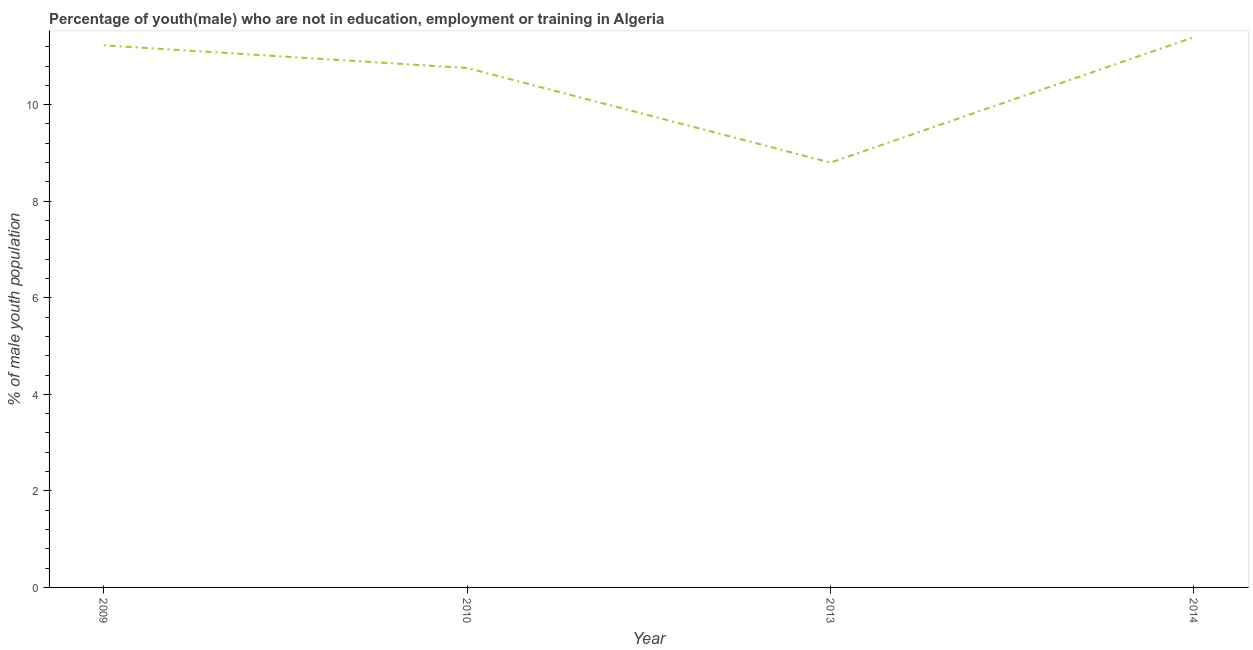What is the unemployed male youth population in 2013?
Provide a short and direct response. 8.8. Across all years, what is the maximum unemployed male youth population?
Ensure brevity in your answer.  11.4. Across all years, what is the minimum unemployed male youth population?
Give a very brief answer. 8.8. What is the sum of the unemployed male youth population?
Your answer should be compact. 42.19. What is the difference between the unemployed male youth population in 2009 and 2014?
Your response must be concise. -0.17. What is the average unemployed male youth population per year?
Ensure brevity in your answer.  10.55. What is the median unemployed male youth population?
Your response must be concise. 10.99. Do a majority of the years between 2010 and 2009 (inclusive) have unemployed male youth population greater than 2.4 %?
Your answer should be very brief. No. What is the ratio of the unemployed male youth population in 2010 to that in 2014?
Your answer should be compact. 0.94. Is the unemployed male youth population in 2009 less than that in 2013?
Your answer should be compact. No. What is the difference between the highest and the second highest unemployed male youth population?
Provide a succinct answer. 0.17. What is the difference between the highest and the lowest unemployed male youth population?
Offer a terse response. 2.6. How many lines are there?
Ensure brevity in your answer.  1. How many years are there in the graph?
Give a very brief answer. 4. What is the difference between two consecutive major ticks on the Y-axis?
Your answer should be very brief. 2. Are the values on the major ticks of Y-axis written in scientific E-notation?
Offer a very short reply. No. Does the graph contain any zero values?
Your response must be concise. No. Does the graph contain grids?
Your answer should be very brief. No. What is the title of the graph?
Your answer should be compact. Percentage of youth(male) who are not in education, employment or training in Algeria. What is the label or title of the Y-axis?
Make the answer very short. % of male youth population. What is the % of male youth population of 2009?
Keep it short and to the point. 11.23. What is the % of male youth population of 2010?
Your response must be concise. 10.76. What is the % of male youth population in 2013?
Offer a terse response. 8.8. What is the % of male youth population of 2014?
Provide a succinct answer. 11.4. What is the difference between the % of male youth population in 2009 and 2010?
Give a very brief answer. 0.47. What is the difference between the % of male youth population in 2009 and 2013?
Your answer should be compact. 2.43. What is the difference between the % of male youth population in 2009 and 2014?
Your answer should be very brief. -0.17. What is the difference between the % of male youth population in 2010 and 2013?
Provide a succinct answer. 1.96. What is the difference between the % of male youth population in 2010 and 2014?
Offer a very short reply. -0.64. What is the ratio of the % of male youth population in 2009 to that in 2010?
Your response must be concise. 1.04. What is the ratio of the % of male youth population in 2009 to that in 2013?
Your answer should be very brief. 1.28. What is the ratio of the % of male youth population in 2010 to that in 2013?
Offer a terse response. 1.22. What is the ratio of the % of male youth population in 2010 to that in 2014?
Your response must be concise. 0.94. What is the ratio of the % of male youth population in 2013 to that in 2014?
Provide a short and direct response. 0.77. 